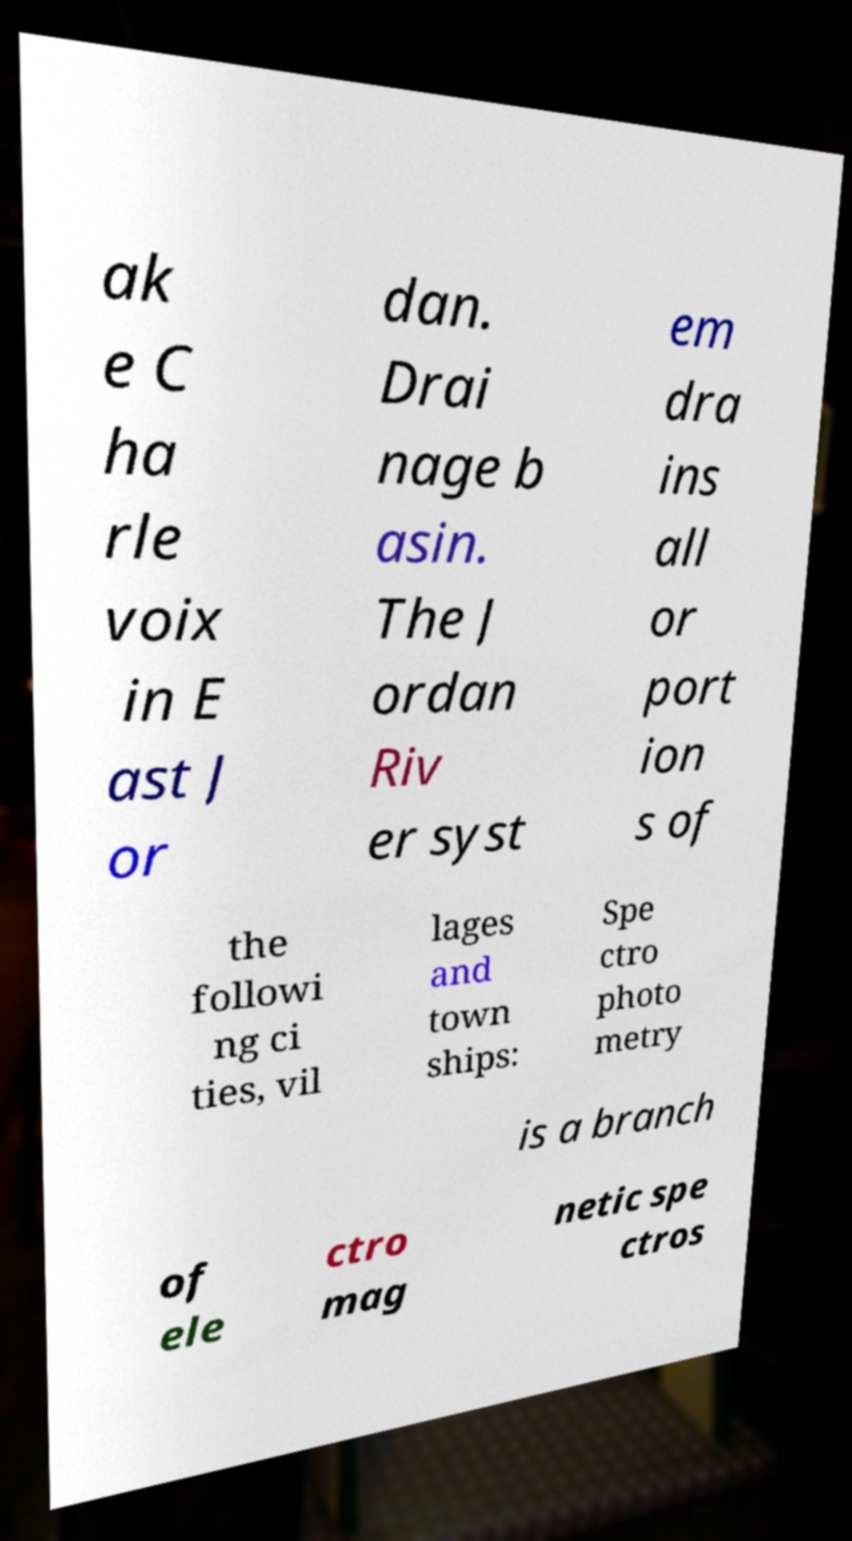I need the written content from this picture converted into text. Can you do that? ak e C ha rle voix in E ast J or dan. Drai nage b asin. The J ordan Riv er syst em dra ins all or port ion s of the followi ng ci ties, vil lages and town ships: Spe ctro photo metry is a branch of ele ctro mag netic spe ctros 